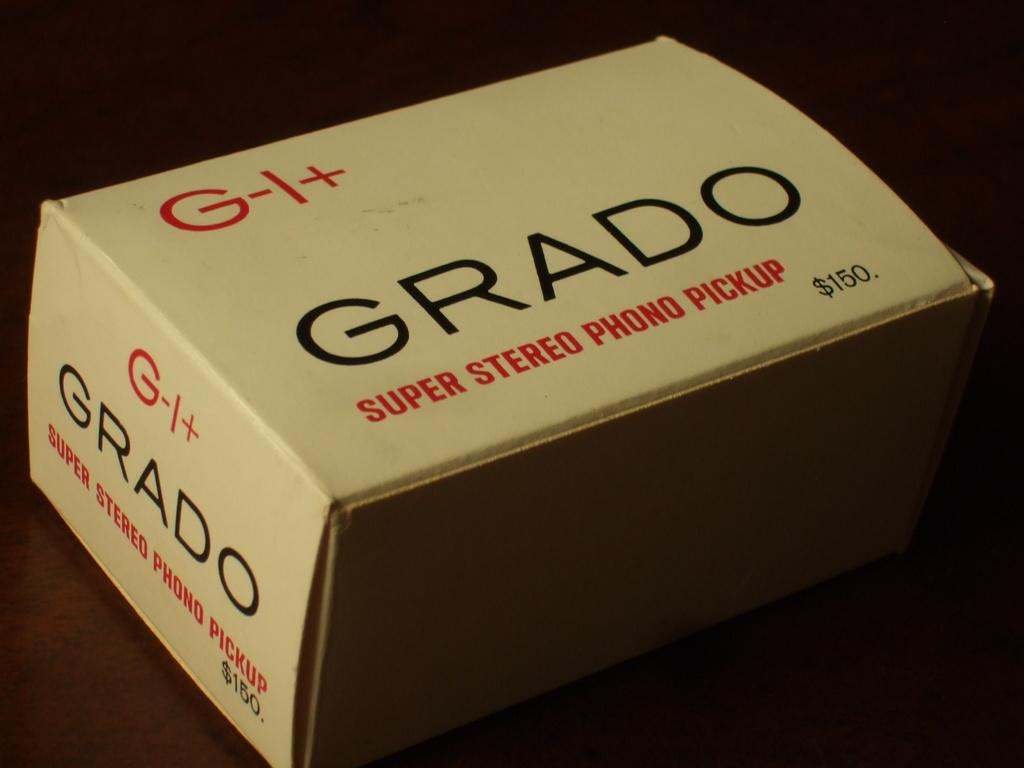<image>
Write a terse but informative summary of the picture. White box with a "G-I+" on it on top of a wooden table. 